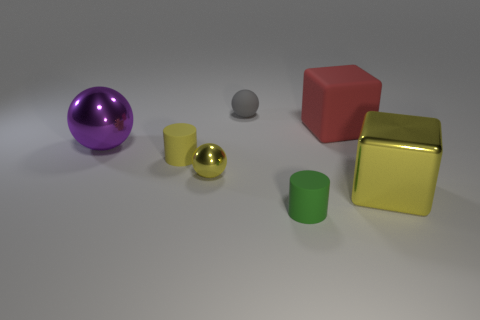What is the material of the block that is the same color as the small metallic sphere?
Provide a short and direct response. Metal. Do the large cube in front of the yellow matte cylinder and the tiny green thing have the same material?
Your answer should be compact. No. Is there a yellow metallic object on the right side of the metallic thing left of the matte cylinder that is behind the tiny green matte object?
Ensure brevity in your answer.  Yes. What number of cylinders are rubber objects or tiny gray rubber objects?
Give a very brief answer. 2. There is a large thing left of the small green matte thing; what is its material?
Offer a very short reply. Metal. What size is the rubber cylinder that is the same color as the small metal ball?
Offer a terse response. Small. Is the color of the cylinder that is behind the green matte thing the same as the small rubber cylinder that is in front of the large yellow metallic block?
Your response must be concise. No. How many things are either tiny shiny balls or blue shiny balls?
Your answer should be very brief. 1. How many other objects are there of the same shape as the tiny gray object?
Your response must be concise. 2. Is the material of the small thing that is in front of the yellow metal ball the same as the cylinder behind the small green rubber cylinder?
Provide a succinct answer. Yes. 